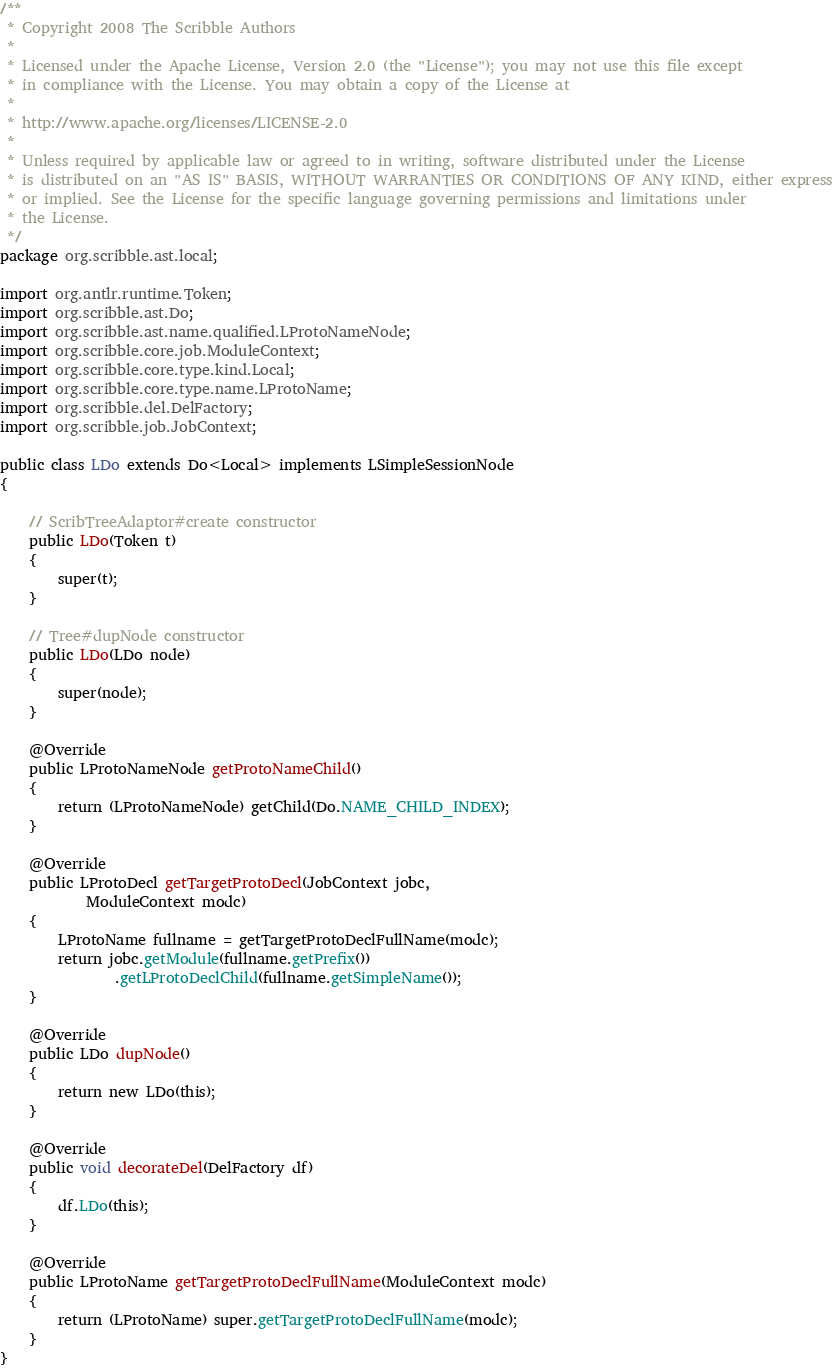<code> <loc_0><loc_0><loc_500><loc_500><_Java_>/**
 * Copyright 2008 The Scribble Authors
 *
 * Licensed under the Apache License, Version 2.0 (the "License"); you may not use this file except
 * in compliance with the License. You may obtain a copy of the License at
 *
 * http://www.apache.org/licenses/LICENSE-2.0
 *
 * Unless required by applicable law or agreed to in writing, software distributed under the License
 * is distributed on an "AS IS" BASIS, WITHOUT WARRANTIES OR CONDITIONS OF ANY KIND, either express
 * or implied. See the License for the specific language governing permissions and limitations under
 * the License.
 */
package org.scribble.ast.local;

import org.antlr.runtime.Token;
import org.scribble.ast.Do;
import org.scribble.ast.name.qualified.LProtoNameNode;
import org.scribble.core.job.ModuleContext;
import org.scribble.core.type.kind.Local;
import org.scribble.core.type.name.LProtoName;
import org.scribble.del.DelFactory;
import org.scribble.job.JobContext;

public class LDo extends Do<Local> implements LSimpleSessionNode
{

	// ScribTreeAdaptor#create constructor
	public LDo(Token t)
	{
		super(t);
	}

	// Tree#dupNode constructor
	public LDo(LDo node)
	{
		super(node);
	}

	@Override
	public LProtoNameNode getProtoNameChild()
	{
		return (LProtoNameNode) getChild(Do.NAME_CHILD_INDEX);
	}

	@Override
	public LProtoDecl getTargetProtoDecl(JobContext jobc,
			ModuleContext modc)
	{
		LProtoName fullname = getTargetProtoDeclFullName(modc);
		return jobc.getModule(fullname.getPrefix())
				.getLProtoDeclChild(fullname.getSimpleName());
	}
	
	@Override
	public LDo dupNode()
	{
		return new LDo(this);
	}
	
	@Override
	public void decorateDel(DelFactory df)
	{
		df.LDo(this);
	}

	@Override
	public LProtoName getTargetProtoDeclFullName(ModuleContext modc)
	{
		return (LProtoName) super.getTargetProtoDeclFullName(modc);
	}
}
</code> 